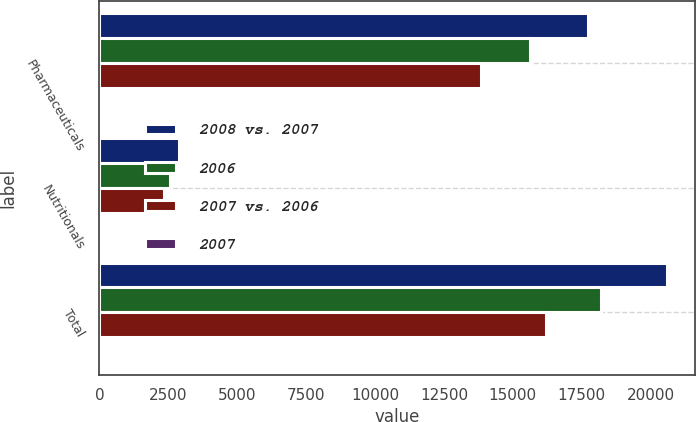Convert chart to OTSL. <chart><loc_0><loc_0><loc_500><loc_500><stacked_bar_chart><ecel><fcel>Pharmaceuticals<fcel>Nutritionals<fcel>Total<nl><fcel>2008 vs. 2007<fcel>17715<fcel>2882<fcel>20597<nl><fcel>2006<fcel>15622<fcel>2571<fcel>18193<nl><fcel>2007 vs. 2006<fcel>13861<fcel>2347<fcel>16208<nl><fcel>2007<fcel>13<fcel>12<fcel>13<nl></chart> 